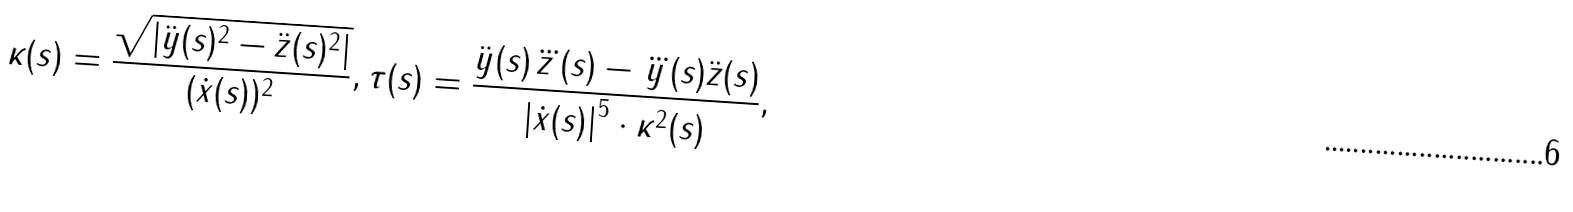Convert formula to latex. <formula><loc_0><loc_0><loc_500><loc_500>\kappa ( s ) = \frac { \sqrt { \left | \ddot { y } ( s ) ^ { 2 } - \ddot { z } ( s ) ^ { 2 } \right | } } { ( \dot { x } ( s ) ) ^ { 2 } } , \tau ( s ) = \frac { \ddot { y } ( s ) \dddot { z } ( s ) - \dddot { y } ( s ) \ddot { z } ( s ) } { \left | \dot { x } ( s ) \right | ^ { 5 } \cdot \kappa ^ { 2 } ( s ) } ,</formula> 